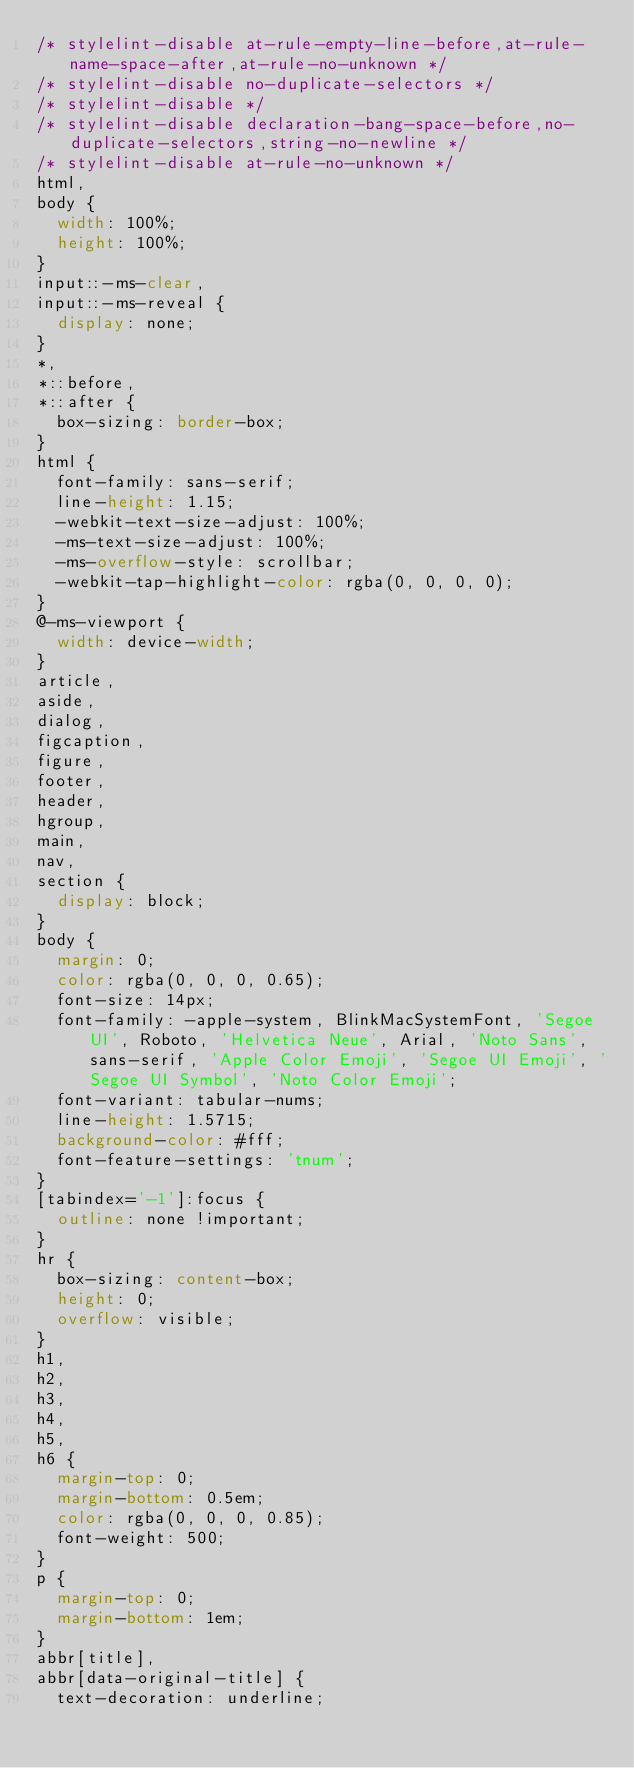<code> <loc_0><loc_0><loc_500><loc_500><_CSS_>/* stylelint-disable at-rule-empty-line-before,at-rule-name-space-after,at-rule-no-unknown */
/* stylelint-disable no-duplicate-selectors */
/* stylelint-disable */
/* stylelint-disable declaration-bang-space-before,no-duplicate-selectors,string-no-newline */
/* stylelint-disable at-rule-no-unknown */
html,
body {
  width: 100%;
  height: 100%;
}
input::-ms-clear,
input::-ms-reveal {
  display: none;
}
*,
*::before,
*::after {
  box-sizing: border-box;
}
html {
  font-family: sans-serif;
  line-height: 1.15;
  -webkit-text-size-adjust: 100%;
  -ms-text-size-adjust: 100%;
  -ms-overflow-style: scrollbar;
  -webkit-tap-highlight-color: rgba(0, 0, 0, 0);
}
@-ms-viewport {
  width: device-width;
}
article,
aside,
dialog,
figcaption,
figure,
footer,
header,
hgroup,
main,
nav,
section {
  display: block;
}
body {
  margin: 0;
  color: rgba(0, 0, 0, 0.65);
  font-size: 14px;
  font-family: -apple-system, BlinkMacSystemFont, 'Segoe UI', Roboto, 'Helvetica Neue', Arial, 'Noto Sans', sans-serif, 'Apple Color Emoji', 'Segoe UI Emoji', 'Segoe UI Symbol', 'Noto Color Emoji';
  font-variant: tabular-nums;
  line-height: 1.5715;
  background-color: #fff;
  font-feature-settings: 'tnum';
}
[tabindex='-1']:focus {
  outline: none !important;
}
hr {
  box-sizing: content-box;
  height: 0;
  overflow: visible;
}
h1,
h2,
h3,
h4,
h5,
h6 {
  margin-top: 0;
  margin-bottom: 0.5em;
  color: rgba(0, 0, 0, 0.85);
  font-weight: 500;
}
p {
  margin-top: 0;
  margin-bottom: 1em;
}
abbr[title],
abbr[data-original-title] {
  text-decoration: underline;</code> 